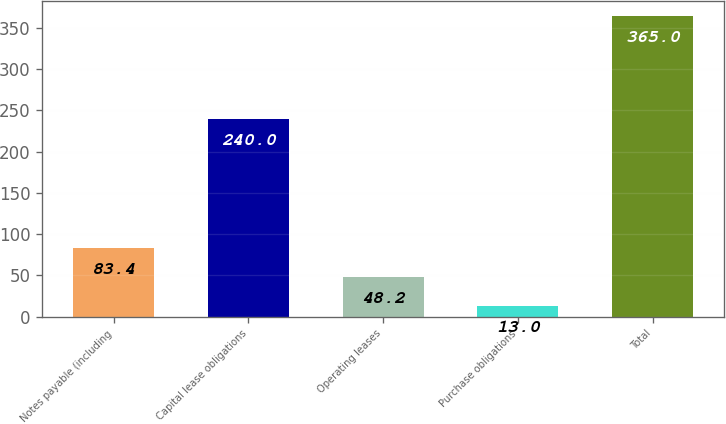Convert chart to OTSL. <chart><loc_0><loc_0><loc_500><loc_500><bar_chart><fcel>Notes payable (including<fcel>Capital lease obligations<fcel>Operating leases<fcel>Purchase obligations<fcel>Total<nl><fcel>83.4<fcel>240<fcel>48.2<fcel>13<fcel>365<nl></chart> 